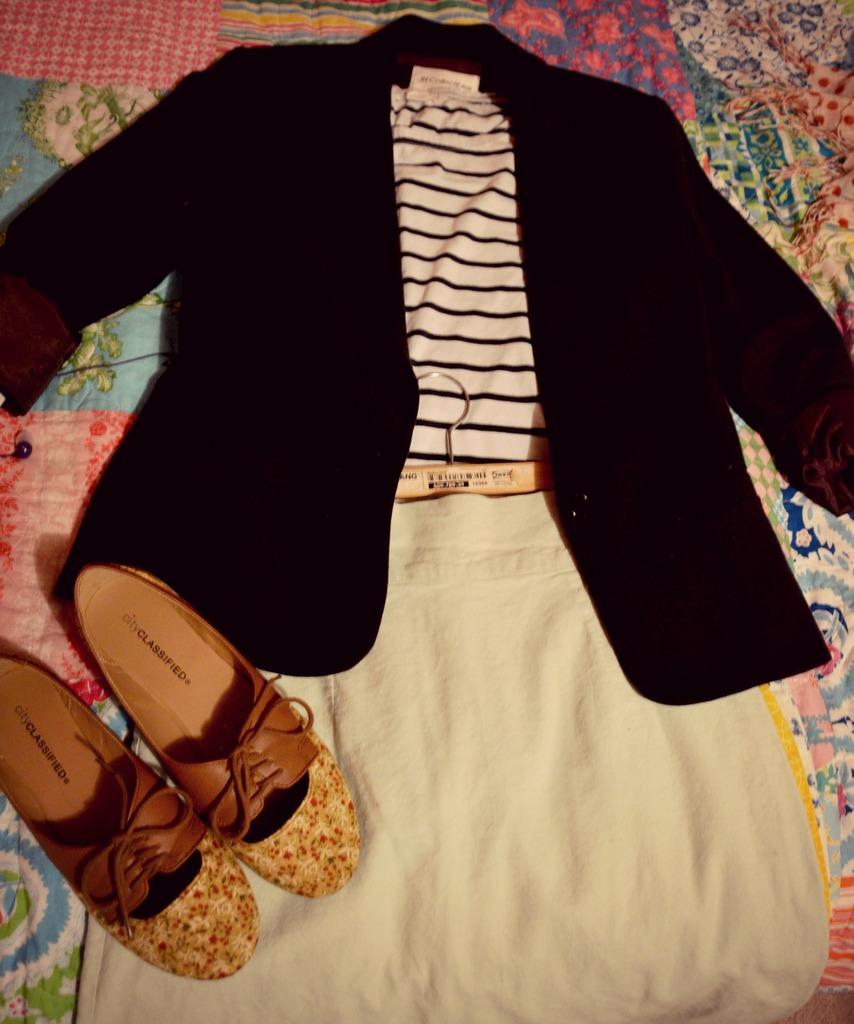What brand are these shoes?
Ensure brevity in your answer.  City classified. What is the first letter in the brand of the shoes?
Offer a very short reply. C. 